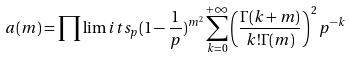<formula> <loc_0><loc_0><loc_500><loc_500>a ( m ) = \prod \lim i t s _ { p } ( 1 - \frac { 1 } { p } ) ^ { m ^ { 2 } } \sum _ { k = 0 } ^ { + \infty } \left ( \frac { \Gamma ( k + m ) } { k ! \Gamma ( m ) } \right ) ^ { 2 } p ^ { - k }</formula> 